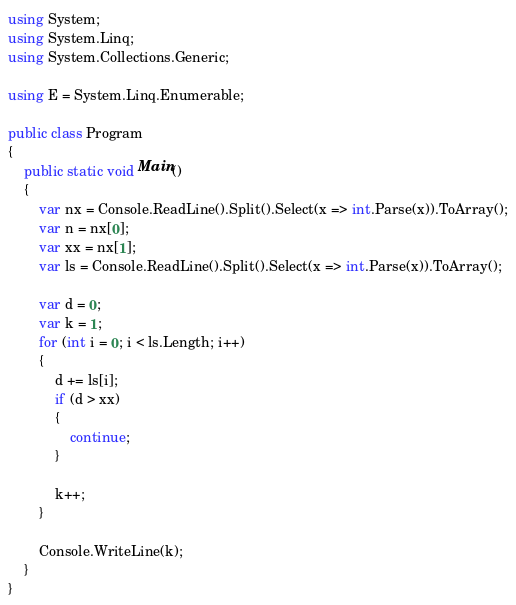Convert code to text. <code><loc_0><loc_0><loc_500><loc_500><_C#_>using System;
using System.Linq;
using System.Collections.Generic;

using E = System.Linq.Enumerable;

public class Program
{
    public static void Main()
    {
        var nx = Console.ReadLine().Split().Select(x => int.Parse(x)).ToArray();
        var n = nx[0];
        var xx = nx[1];
        var ls = Console.ReadLine().Split().Select(x => int.Parse(x)).ToArray();

        var d = 0;
        var k = 1;
        for (int i = 0; i < ls.Length; i++)
        {
            d += ls[i];
            if (d > xx)
            {
                continue;
            }

            k++;
        }
        
        Console.WriteLine(k);
    }
}
</code> 